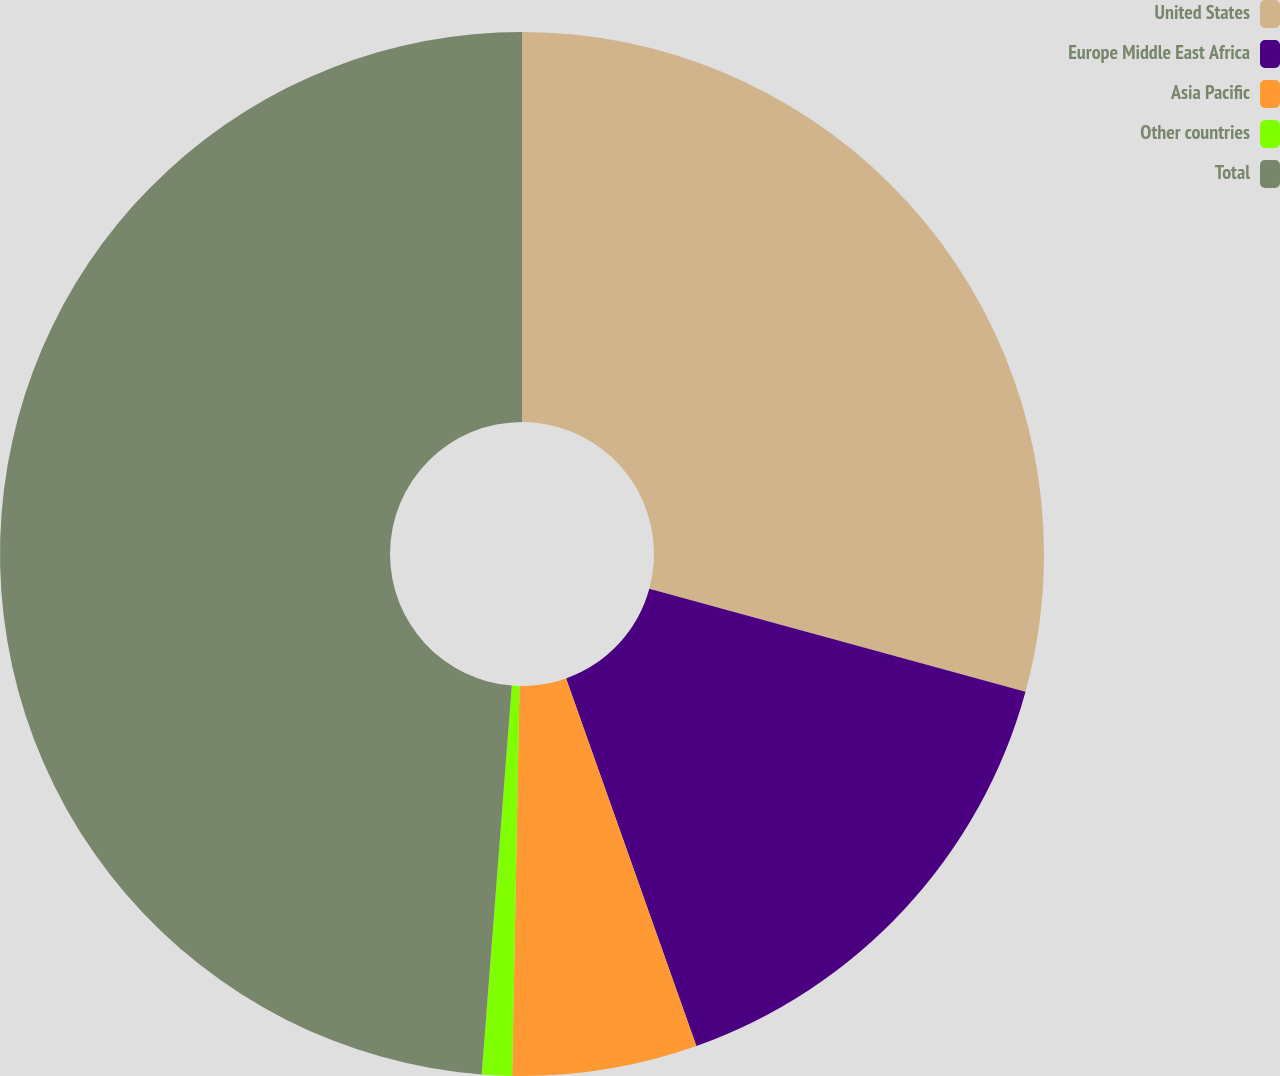<chart> <loc_0><loc_0><loc_500><loc_500><pie_chart><fcel>United States<fcel>Europe Middle East Africa<fcel>Asia Pacific<fcel>Other countries<fcel>Total<nl><fcel>29.25%<fcel>15.33%<fcel>5.72%<fcel>0.93%<fcel>48.77%<nl></chart> 